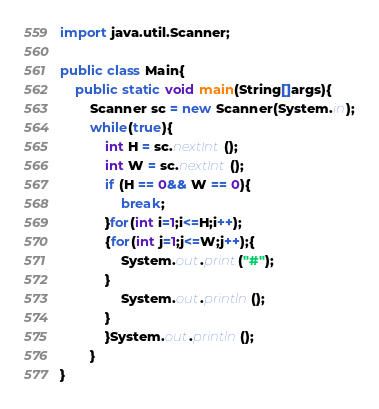<code> <loc_0><loc_0><loc_500><loc_500><_Java_>import java.util.Scanner;

public class Main{
	public static void main(String[]args){
		Scanner sc = new Scanner(System.in);
	    while(true){
	    	int H = sc.nextInt();
	    	int W = sc.nextInt();
	    	if (H == 0&& W == 0){
	    		break;
	    	}for(int i=1;i<=H;i++);
	    	{for(int j=1;j<=W;j++);{
	    		System.out.print("#");
	    	}
	    		System.out.println();
	    	}
	    	}System.out.println();
	    }
}</code> 